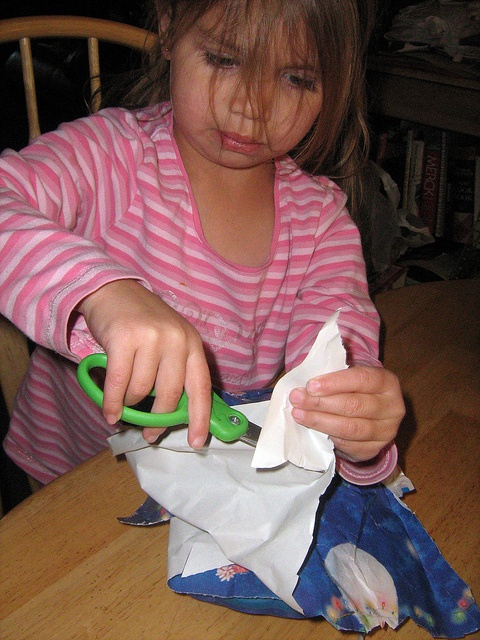Describe the objects in this image and their specific colors. I can see people in black, brown, lightpink, and salmon tones, dining table in black, olive, and maroon tones, chair in black, maroon, and gray tones, scissors in black, green, and lightgreen tones, and chair in black, maroon, and brown tones in this image. 